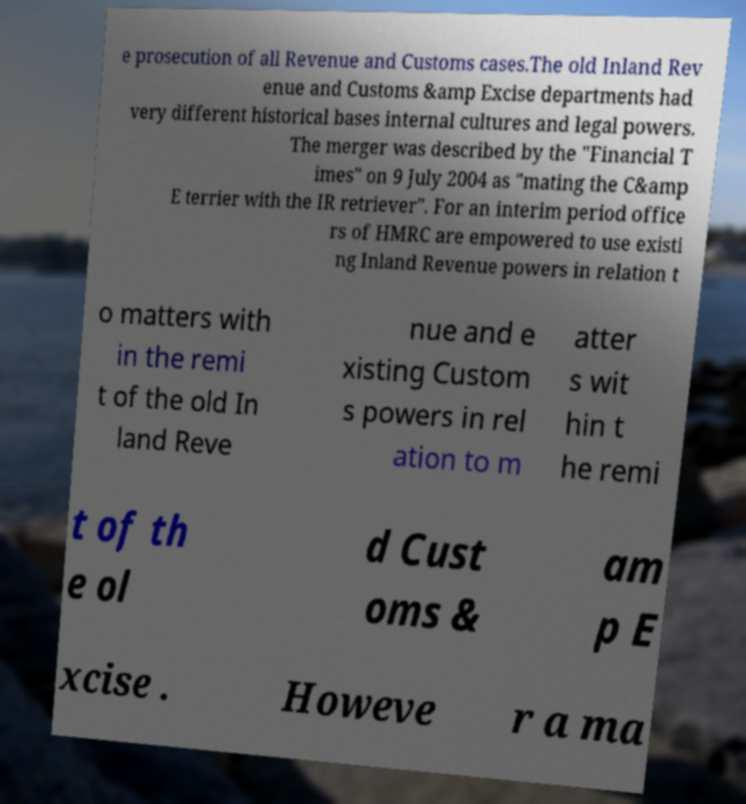Please read and relay the text visible in this image. What does it say? e prosecution of all Revenue and Customs cases.The old Inland Rev enue and Customs &amp Excise departments had very different historical bases internal cultures and legal powers. The merger was described by the "Financial T imes" on 9 July 2004 as "mating the C&amp E terrier with the IR retriever". For an interim period office rs of HMRC are empowered to use existi ng Inland Revenue powers in relation t o matters with in the remi t of the old In land Reve nue and e xisting Custom s powers in rel ation to m atter s wit hin t he remi t of th e ol d Cust oms & am p E xcise . Howeve r a ma 